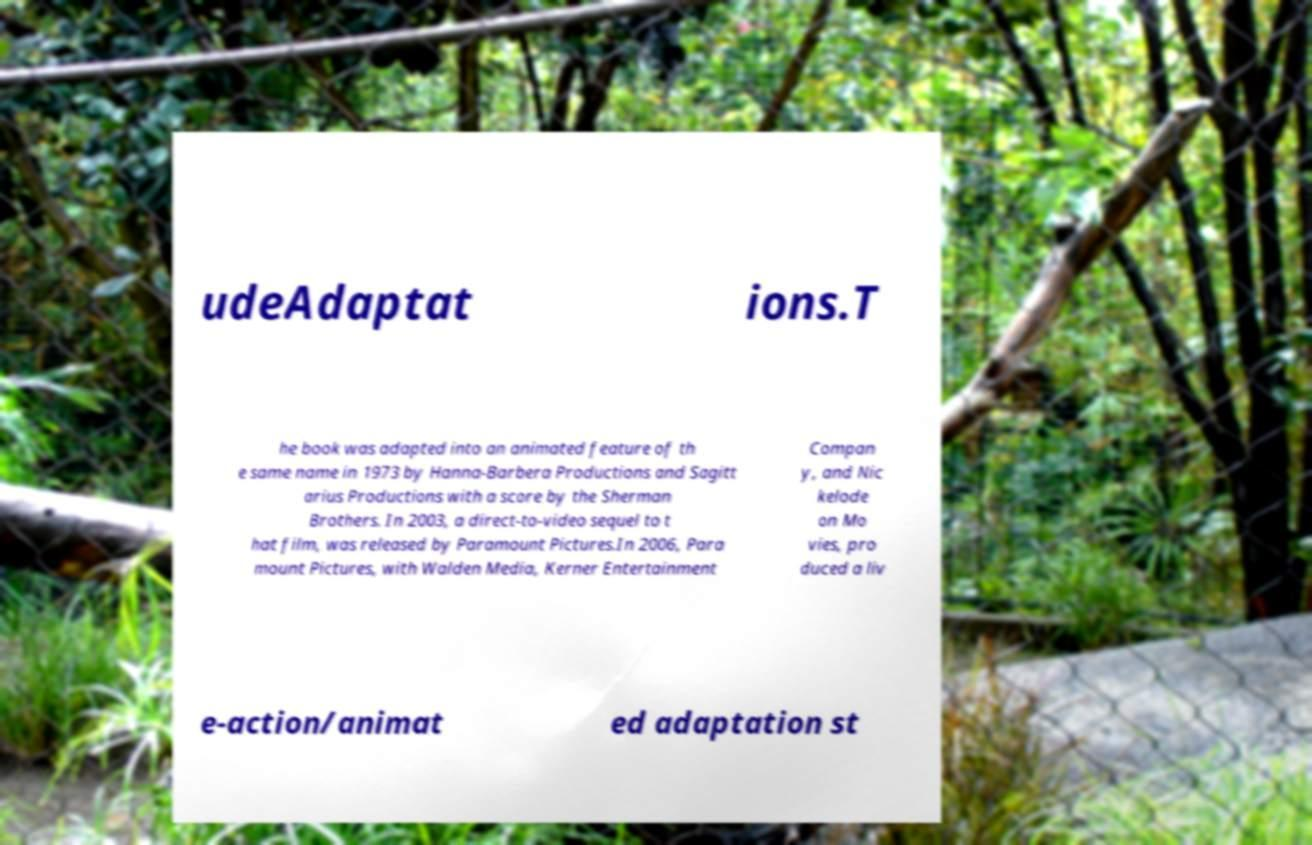I need the written content from this picture converted into text. Can you do that? udeAdaptat ions.T he book was adapted into an animated feature of th e same name in 1973 by Hanna-Barbera Productions and Sagitt arius Productions with a score by the Sherman Brothers. In 2003, a direct-to-video sequel to t hat film, was released by Paramount Pictures.In 2006, Para mount Pictures, with Walden Media, Kerner Entertainment Compan y, and Nic kelode on Mo vies, pro duced a liv e-action/animat ed adaptation st 